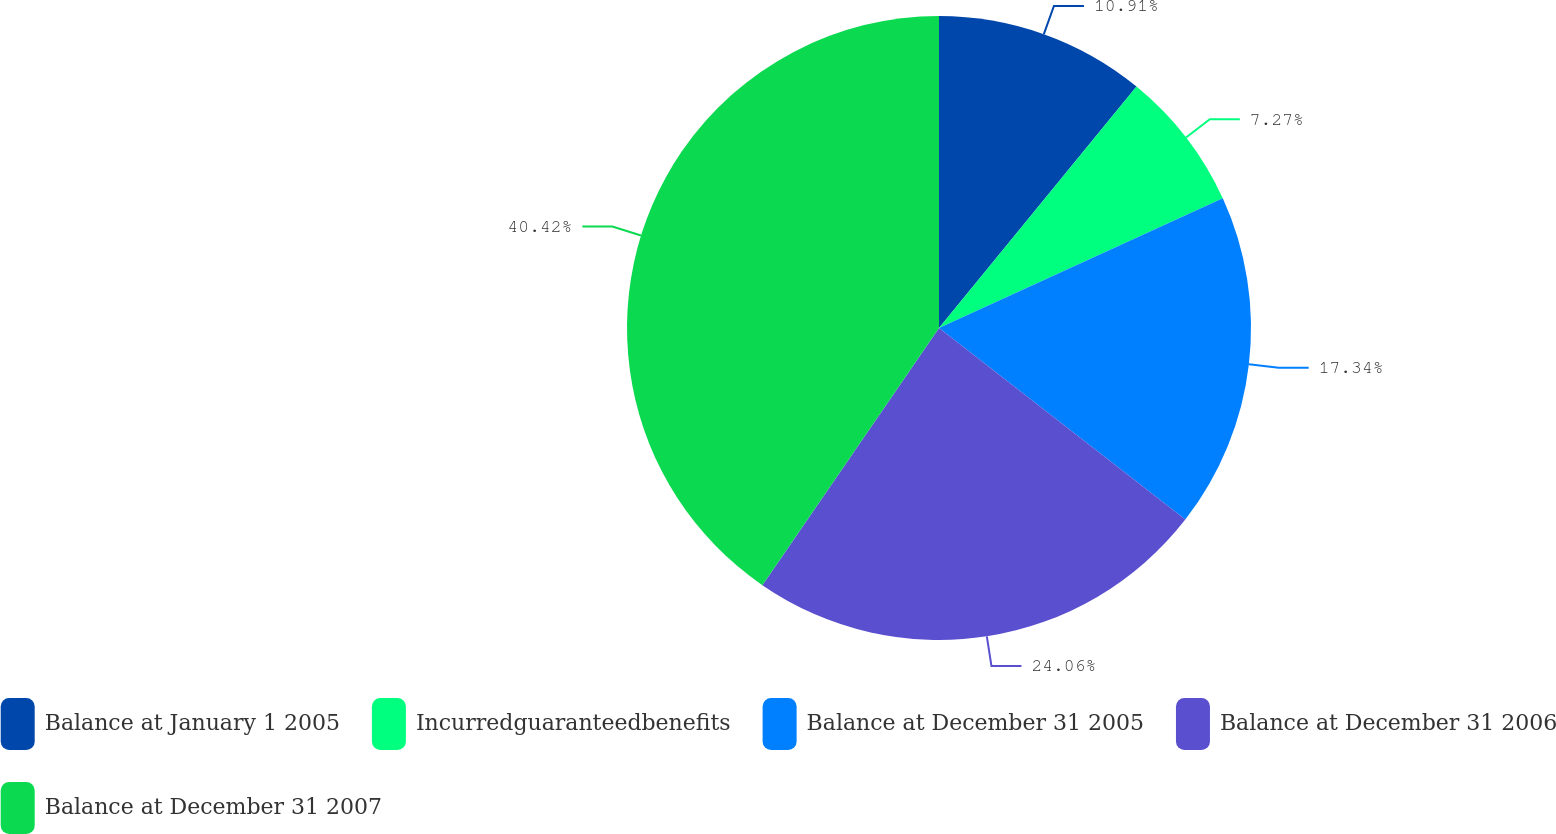<chart> <loc_0><loc_0><loc_500><loc_500><pie_chart><fcel>Balance at January 1 2005<fcel>Incurredguaranteedbenefits<fcel>Balance at December 31 2005<fcel>Balance at December 31 2006<fcel>Balance at December 31 2007<nl><fcel>10.91%<fcel>7.27%<fcel>17.34%<fcel>24.06%<fcel>40.42%<nl></chart> 